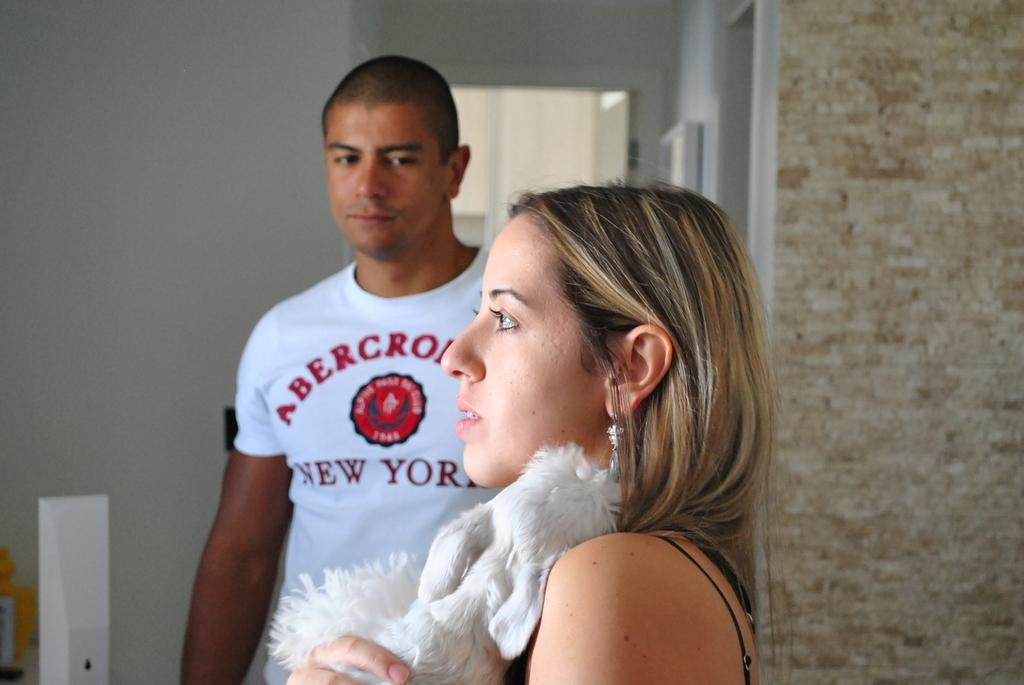What is the lady holding in the image? The lady is holding a puppy in the image. What is the man wearing in the image? The man is wearing a white color t-shirt in the image. What can be seen in the background of the image? There is a door and a wall in the background of the image. What type of berry is the man eating in the image? There is no berry present in the image; the man is wearing a white color t-shirt. What memory does the lady have of the puppy in the image? The image does not provide any information about the lady's memories of the puppy. 